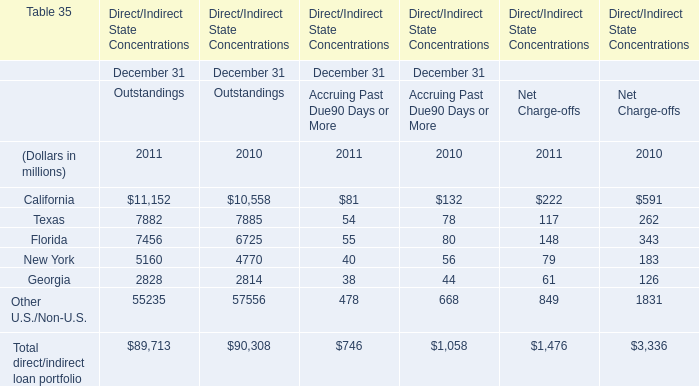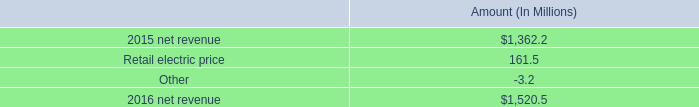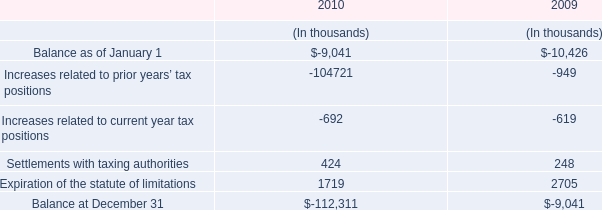In the year with the most New York in Outstandings in table 0, what is the growth rate of Florida in Outstandings in table 0? 
Computations: ((7456 - 6725) / 6725)
Answer: 0.1087. 